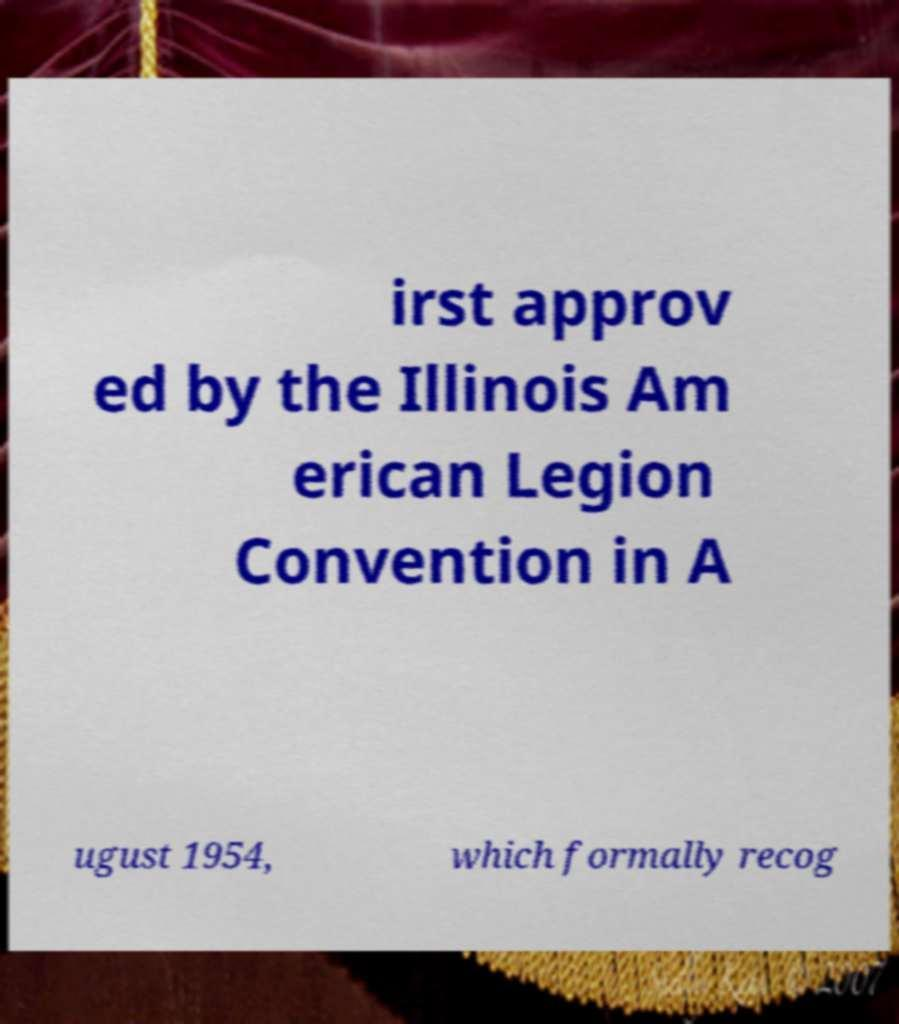Please identify and transcribe the text found in this image. irst approv ed by the Illinois Am erican Legion Convention in A ugust 1954, which formally recog 